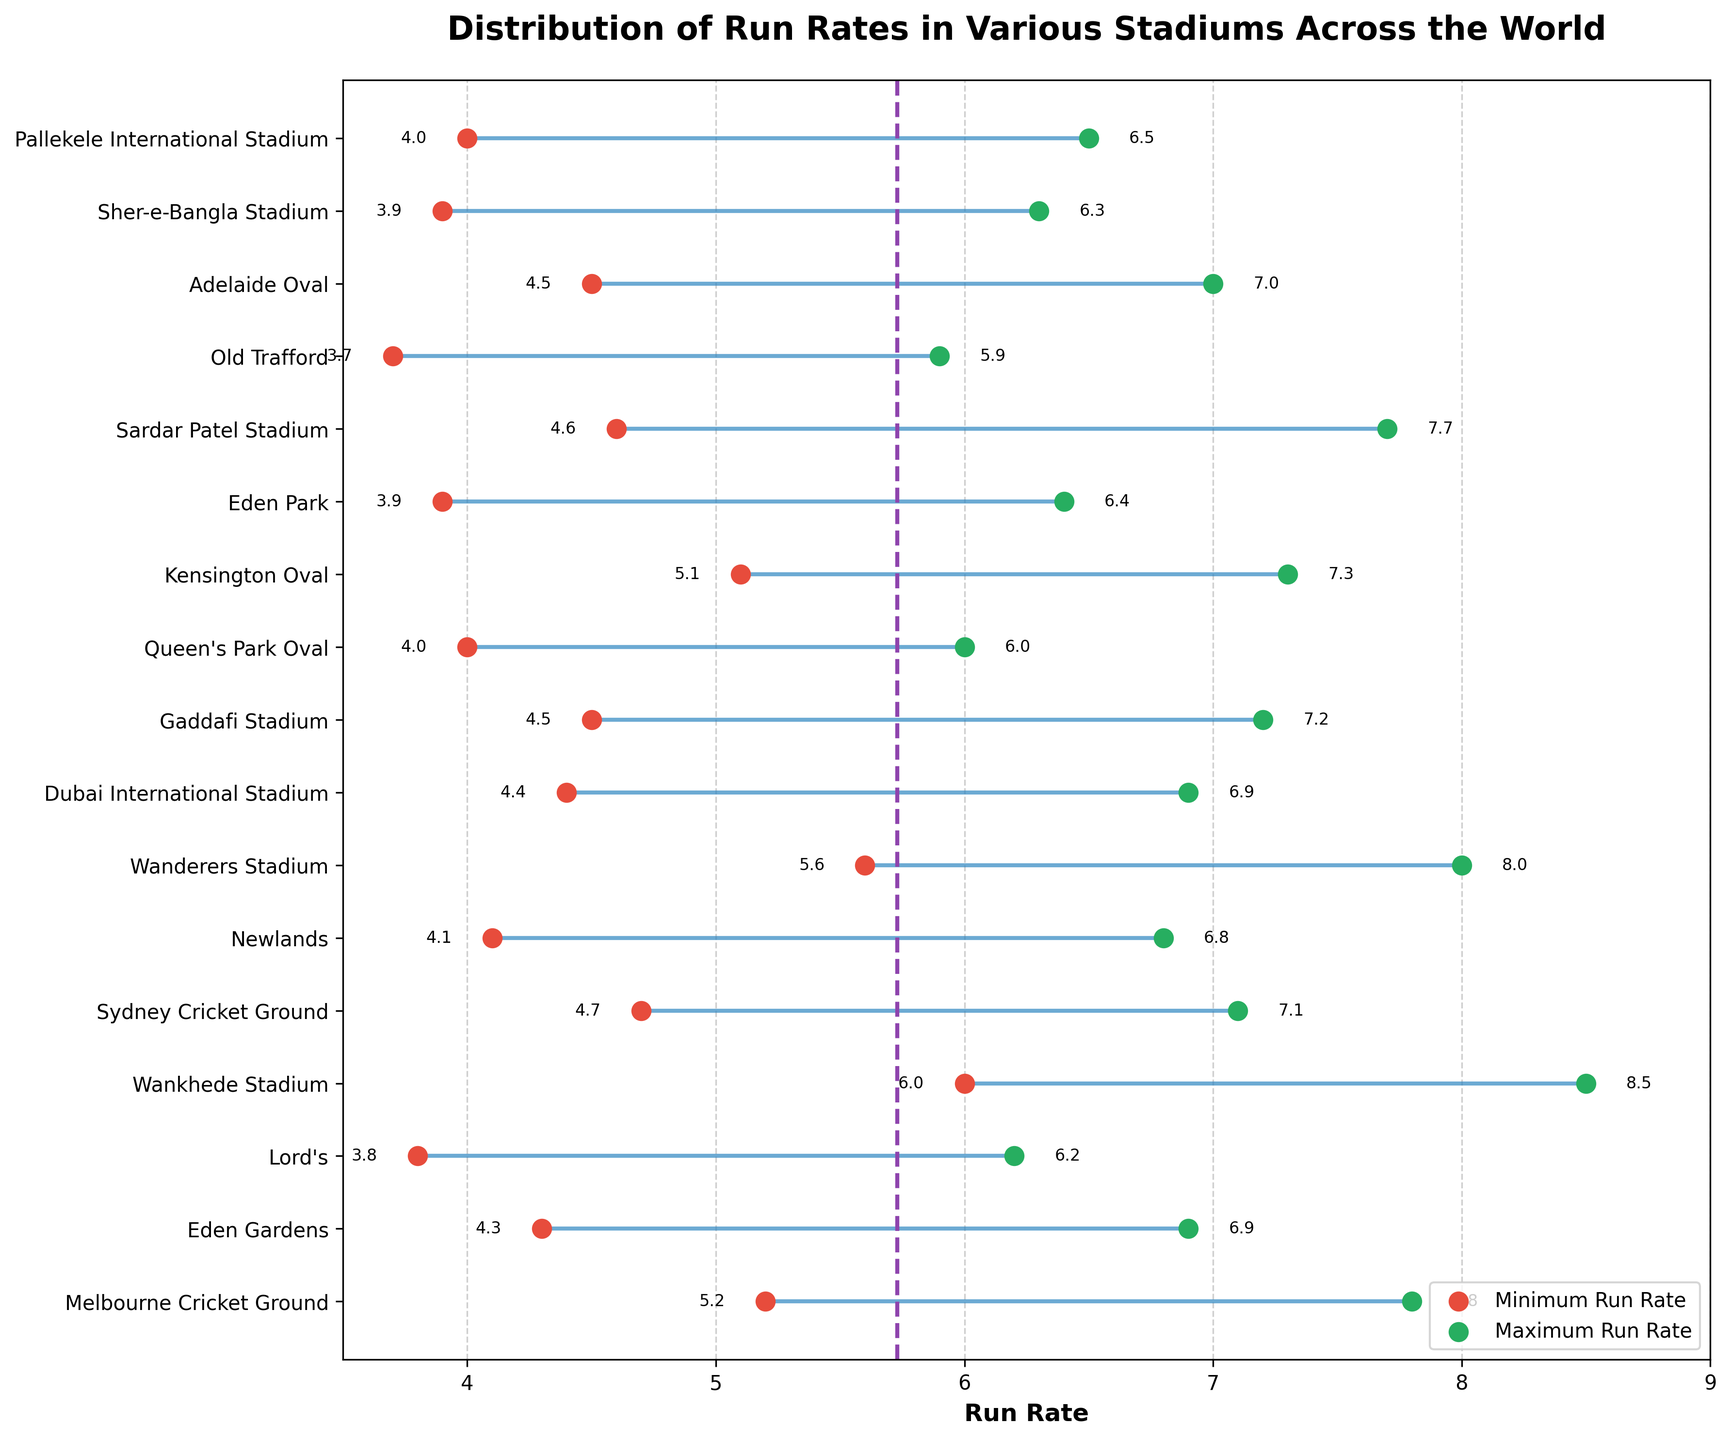What's the range of run rates observed for Melbourne Cricket Ground? Look at the horizontal line for Melbourne Cricket Ground. The minimum run rate is labeled as 5.2 and the maximum run rate is labeled as 7.8.
Answer: 5.2 to 7.8 Which stadium has the highest maximum run rate? Find the dot corresponding to the highest point on the x-axis. The Wankhede Stadium has a maximum run rate of 8.5, which is the highest among the stadiums.
Answer: Wankhede Stadium Which stadium has the lowest minimum run rate? Find the dot corresponding to the lowest point on the x-axis. The lowest minimum run rate of 3.7 is for Old Trafford.
Answer: Old Trafford What is the average run rate for Sydney Cricket Ground? To find the average run rate, add the minimum and maximum run rates for Sydney Cricket Ground (4.7 + 7.1) and then divide by 2: (4.7 + 7.1) / 2 = 5.9.
Answer: 5.9 How many stadiums have a minimum run rate of 4.0 or lower? Count the dots along the x-axis that are 4.0 or lower. There are four stadiums: Queen's Park Oval, Eden Park, Sher-e-Bangla Stadium, and Pallekele International Stadium.
Answer: 4 What is the maximum range of run rates observed among the stadiums? The range is calculated by subtracting the minimum run rate from the maximum run rate for each stadium. The highest range is for Wankhede Stadium, where the maximum run rate is 8.5 and the minimum run rate is 6.0, resulting in a range of 8.5 - 6.0 = 2.5.
Answer: 2.5 Are there any stadiums with average run rates above the overall average line? Look at the stadiums that are above the dotted average line. Any stadium with an average higher than approximately 5.89 would qualify. These include Wankhede Stadium, Wanderers Stadium, and Melbourne Cricket Ground.
Answer: Yes Which stadium in India has the lowest maximum run rate? Compare the maximum run rates of Indian stadiums: Eden Gardens (6.9), Wankhede Stadium (8.5), Sardar Patel Stadium (7.7), and Wankhede Stadium. The lowest maximum run rate among them is Eden Gardens with 6.9.
Answer: Eden Gardens Which country has the most stadiums in the list? Count the stadiums for each country. India has four stadiums: Eden Gardens, Wankhede Stadium, Sardar Patel Stadium, and another.
Answer: India 